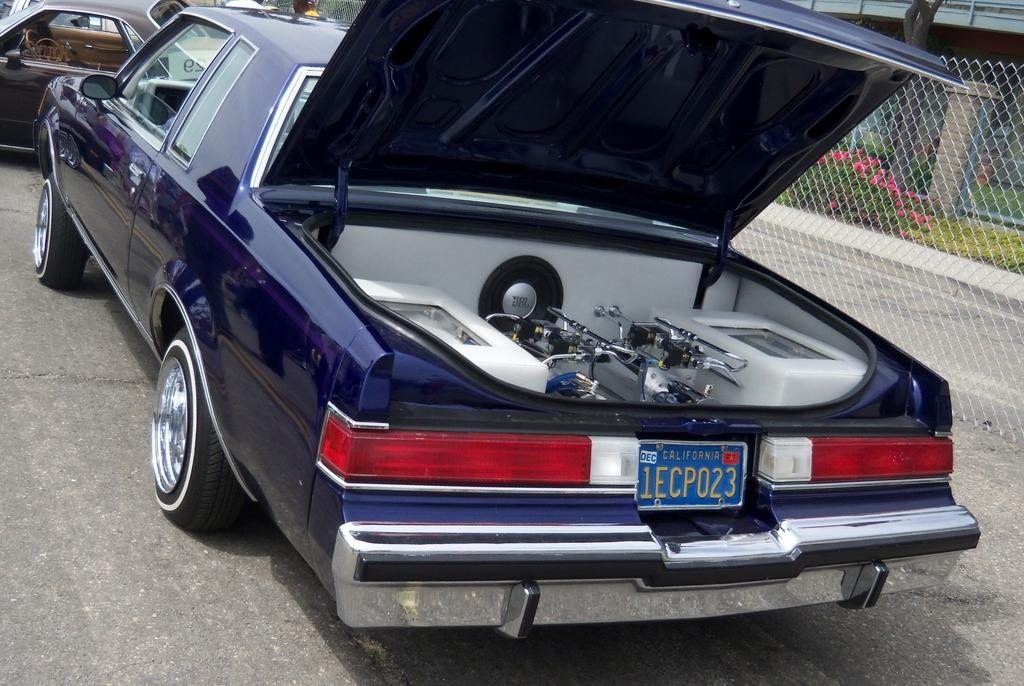<image>
Provide a brief description of the given image. A blue car with California plate 1ECP023 sits in a parking lot with the window down and the trunk open. 